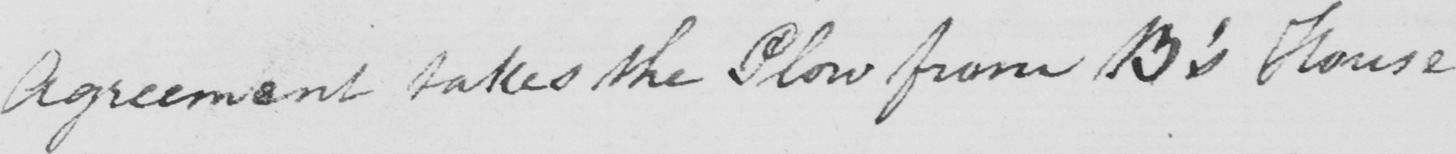Please transcribe the handwritten text in this image. Agreement takes the Plow from B ' s House 